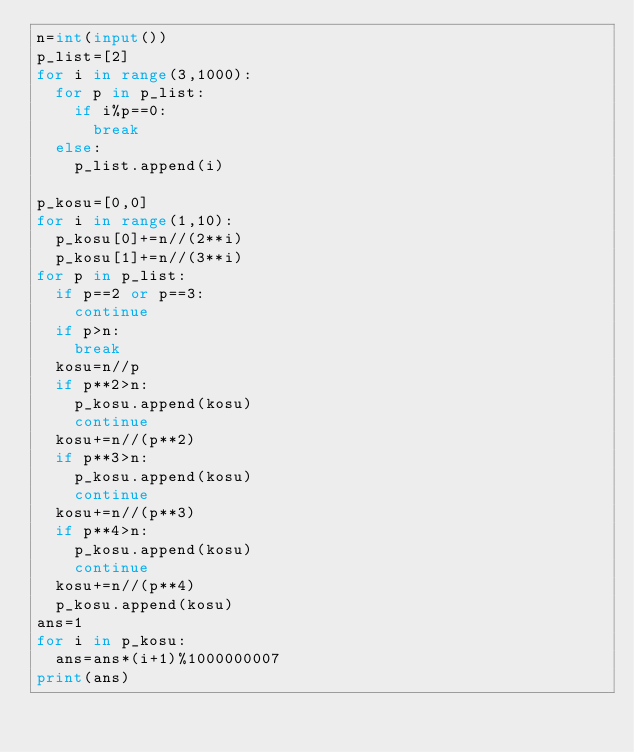Convert code to text. <code><loc_0><loc_0><loc_500><loc_500><_Python_>n=int(input())
p_list=[2]
for i in range(3,1000):
  for p in p_list:
    if i%p==0:
      break
  else:
    p_list.append(i)

p_kosu=[0,0]
for i in range(1,10):
  p_kosu[0]+=n//(2**i)
  p_kosu[1]+=n//(3**i)
for p in p_list:
  if p==2 or p==3:
    continue
  if p>n:
    break
  kosu=n//p
  if p**2>n:
    p_kosu.append(kosu)
    continue
  kosu+=n//(p**2)
  if p**3>n:
    p_kosu.append(kosu)
    continue
  kosu+=n//(p**3)
  if p**4>n:
    p_kosu.append(kosu)
    continue
  kosu+=n//(p**4)
  p_kosu.append(kosu)
ans=1
for i in p_kosu:
  ans=ans*(i+1)%1000000007
print(ans)</code> 